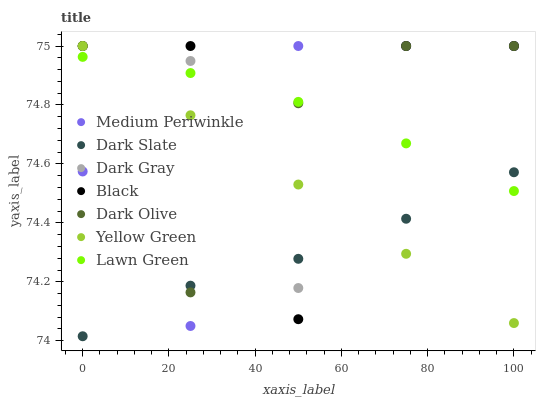Does Dark Slate have the minimum area under the curve?
Answer yes or no. Yes. Does Dark Gray have the maximum area under the curve?
Answer yes or no. Yes. Does Yellow Green have the minimum area under the curve?
Answer yes or no. No. Does Yellow Green have the maximum area under the curve?
Answer yes or no. No. Is Yellow Green the smoothest?
Answer yes or no. Yes. Is Black the roughest?
Answer yes or no. Yes. Is Dark Olive the smoothest?
Answer yes or no. No. Is Dark Olive the roughest?
Answer yes or no. No. Does Dark Slate have the lowest value?
Answer yes or no. Yes. Does Yellow Green have the lowest value?
Answer yes or no. No. Does Black have the highest value?
Answer yes or no. Yes. Does Dark Slate have the highest value?
Answer yes or no. No. Does Yellow Green intersect Dark Gray?
Answer yes or no. Yes. Is Yellow Green less than Dark Gray?
Answer yes or no. No. Is Yellow Green greater than Dark Gray?
Answer yes or no. No. 